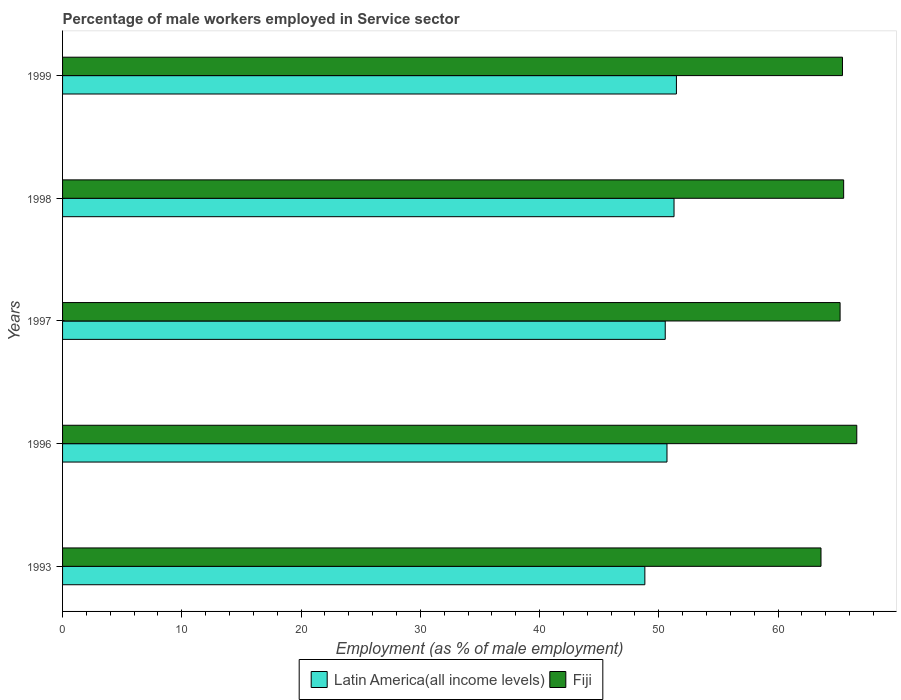Are the number of bars on each tick of the Y-axis equal?
Your response must be concise. Yes. How many bars are there on the 4th tick from the bottom?
Offer a very short reply. 2. What is the percentage of male workers employed in Service sector in Fiji in 1993?
Offer a very short reply. 63.6. Across all years, what is the maximum percentage of male workers employed in Service sector in Fiji?
Your answer should be compact. 66.6. Across all years, what is the minimum percentage of male workers employed in Service sector in Latin America(all income levels)?
Make the answer very short. 48.83. In which year was the percentage of male workers employed in Service sector in Fiji minimum?
Make the answer very short. 1993. What is the total percentage of male workers employed in Service sector in Fiji in the graph?
Offer a terse response. 326.3. What is the difference between the percentage of male workers employed in Service sector in Fiji in 1993 and that in 1998?
Give a very brief answer. -1.9. What is the difference between the percentage of male workers employed in Service sector in Fiji in 1993 and the percentage of male workers employed in Service sector in Latin America(all income levels) in 1997?
Provide a succinct answer. 13.06. What is the average percentage of male workers employed in Service sector in Fiji per year?
Ensure brevity in your answer.  65.26. In the year 1998, what is the difference between the percentage of male workers employed in Service sector in Latin America(all income levels) and percentage of male workers employed in Service sector in Fiji?
Your answer should be very brief. -14.22. What is the ratio of the percentage of male workers employed in Service sector in Fiji in 1996 to that in 1999?
Give a very brief answer. 1.02. Is the percentage of male workers employed in Service sector in Fiji in 1993 less than that in 1999?
Offer a very short reply. Yes. Is the difference between the percentage of male workers employed in Service sector in Latin America(all income levels) in 1997 and 1999 greater than the difference between the percentage of male workers employed in Service sector in Fiji in 1997 and 1999?
Provide a succinct answer. No. What is the difference between the highest and the second highest percentage of male workers employed in Service sector in Fiji?
Your answer should be compact. 1.1. What is the difference between the highest and the lowest percentage of male workers employed in Service sector in Latin America(all income levels)?
Offer a very short reply. 2.65. In how many years, is the percentage of male workers employed in Service sector in Fiji greater than the average percentage of male workers employed in Service sector in Fiji taken over all years?
Make the answer very short. 3. Is the sum of the percentage of male workers employed in Service sector in Fiji in 1996 and 1998 greater than the maximum percentage of male workers employed in Service sector in Latin America(all income levels) across all years?
Your response must be concise. Yes. What does the 2nd bar from the top in 1993 represents?
Make the answer very short. Latin America(all income levels). What does the 2nd bar from the bottom in 1996 represents?
Provide a short and direct response. Fiji. How many bars are there?
Keep it short and to the point. 10. Does the graph contain grids?
Offer a terse response. No. How many legend labels are there?
Provide a short and direct response. 2. How are the legend labels stacked?
Give a very brief answer. Horizontal. What is the title of the graph?
Ensure brevity in your answer.  Percentage of male workers employed in Service sector. What is the label or title of the X-axis?
Provide a short and direct response. Employment (as % of male employment). What is the Employment (as % of male employment) of Latin America(all income levels) in 1993?
Make the answer very short. 48.83. What is the Employment (as % of male employment) in Fiji in 1993?
Your answer should be compact. 63.6. What is the Employment (as % of male employment) in Latin America(all income levels) in 1996?
Your response must be concise. 50.68. What is the Employment (as % of male employment) in Fiji in 1996?
Offer a very short reply. 66.6. What is the Employment (as % of male employment) in Latin America(all income levels) in 1997?
Ensure brevity in your answer.  50.54. What is the Employment (as % of male employment) in Fiji in 1997?
Offer a very short reply. 65.2. What is the Employment (as % of male employment) of Latin America(all income levels) in 1998?
Provide a short and direct response. 51.28. What is the Employment (as % of male employment) in Fiji in 1998?
Offer a very short reply. 65.5. What is the Employment (as % of male employment) of Latin America(all income levels) in 1999?
Offer a terse response. 51.48. What is the Employment (as % of male employment) in Fiji in 1999?
Offer a terse response. 65.4. Across all years, what is the maximum Employment (as % of male employment) in Latin America(all income levels)?
Your response must be concise. 51.48. Across all years, what is the maximum Employment (as % of male employment) of Fiji?
Offer a terse response. 66.6. Across all years, what is the minimum Employment (as % of male employment) in Latin America(all income levels)?
Ensure brevity in your answer.  48.83. Across all years, what is the minimum Employment (as % of male employment) of Fiji?
Provide a short and direct response. 63.6. What is the total Employment (as % of male employment) in Latin America(all income levels) in the graph?
Your answer should be very brief. 252.8. What is the total Employment (as % of male employment) in Fiji in the graph?
Provide a succinct answer. 326.3. What is the difference between the Employment (as % of male employment) of Latin America(all income levels) in 1993 and that in 1996?
Provide a succinct answer. -1.86. What is the difference between the Employment (as % of male employment) in Latin America(all income levels) in 1993 and that in 1997?
Your answer should be very brief. -1.71. What is the difference between the Employment (as % of male employment) of Fiji in 1993 and that in 1997?
Your answer should be compact. -1.6. What is the difference between the Employment (as % of male employment) of Latin America(all income levels) in 1993 and that in 1998?
Give a very brief answer. -2.45. What is the difference between the Employment (as % of male employment) in Fiji in 1993 and that in 1998?
Make the answer very short. -1.9. What is the difference between the Employment (as % of male employment) of Latin America(all income levels) in 1993 and that in 1999?
Give a very brief answer. -2.65. What is the difference between the Employment (as % of male employment) in Fiji in 1993 and that in 1999?
Give a very brief answer. -1.8. What is the difference between the Employment (as % of male employment) in Latin America(all income levels) in 1996 and that in 1997?
Ensure brevity in your answer.  0.15. What is the difference between the Employment (as % of male employment) of Fiji in 1996 and that in 1997?
Provide a short and direct response. 1.4. What is the difference between the Employment (as % of male employment) in Latin America(all income levels) in 1996 and that in 1998?
Your response must be concise. -0.59. What is the difference between the Employment (as % of male employment) in Latin America(all income levels) in 1996 and that in 1999?
Provide a succinct answer. -0.79. What is the difference between the Employment (as % of male employment) of Latin America(all income levels) in 1997 and that in 1998?
Offer a terse response. -0.74. What is the difference between the Employment (as % of male employment) in Fiji in 1997 and that in 1998?
Your response must be concise. -0.3. What is the difference between the Employment (as % of male employment) of Latin America(all income levels) in 1997 and that in 1999?
Your response must be concise. -0.94. What is the difference between the Employment (as % of male employment) in Fiji in 1997 and that in 1999?
Your answer should be compact. -0.2. What is the difference between the Employment (as % of male employment) of Latin America(all income levels) in 1998 and that in 1999?
Ensure brevity in your answer.  -0.2. What is the difference between the Employment (as % of male employment) of Fiji in 1998 and that in 1999?
Your response must be concise. 0.1. What is the difference between the Employment (as % of male employment) of Latin America(all income levels) in 1993 and the Employment (as % of male employment) of Fiji in 1996?
Give a very brief answer. -17.77. What is the difference between the Employment (as % of male employment) of Latin America(all income levels) in 1993 and the Employment (as % of male employment) of Fiji in 1997?
Ensure brevity in your answer.  -16.37. What is the difference between the Employment (as % of male employment) of Latin America(all income levels) in 1993 and the Employment (as % of male employment) of Fiji in 1998?
Your answer should be very brief. -16.67. What is the difference between the Employment (as % of male employment) of Latin America(all income levels) in 1993 and the Employment (as % of male employment) of Fiji in 1999?
Provide a succinct answer. -16.57. What is the difference between the Employment (as % of male employment) in Latin America(all income levels) in 1996 and the Employment (as % of male employment) in Fiji in 1997?
Your answer should be very brief. -14.52. What is the difference between the Employment (as % of male employment) in Latin America(all income levels) in 1996 and the Employment (as % of male employment) in Fiji in 1998?
Your answer should be very brief. -14.82. What is the difference between the Employment (as % of male employment) in Latin America(all income levels) in 1996 and the Employment (as % of male employment) in Fiji in 1999?
Your answer should be very brief. -14.72. What is the difference between the Employment (as % of male employment) of Latin America(all income levels) in 1997 and the Employment (as % of male employment) of Fiji in 1998?
Provide a succinct answer. -14.96. What is the difference between the Employment (as % of male employment) in Latin America(all income levels) in 1997 and the Employment (as % of male employment) in Fiji in 1999?
Keep it short and to the point. -14.86. What is the difference between the Employment (as % of male employment) of Latin America(all income levels) in 1998 and the Employment (as % of male employment) of Fiji in 1999?
Provide a short and direct response. -14.12. What is the average Employment (as % of male employment) of Latin America(all income levels) per year?
Your response must be concise. 50.56. What is the average Employment (as % of male employment) of Fiji per year?
Your answer should be very brief. 65.26. In the year 1993, what is the difference between the Employment (as % of male employment) in Latin America(all income levels) and Employment (as % of male employment) in Fiji?
Your response must be concise. -14.77. In the year 1996, what is the difference between the Employment (as % of male employment) in Latin America(all income levels) and Employment (as % of male employment) in Fiji?
Provide a succinct answer. -15.92. In the year 1997, what is the difference between the Employment (as % of male employment) in Latin America(all income levels) and Employment (as % of male employment) in Fiji?
Provide a short and direct response. -14.66. In the year 1998, what is the difference between the Employment (as % of male employment) of Latin America(all income levels) and Employment (as % of male employment) of Fiji?
Ensure brevity in your answer.  -14.22. In the year 1999, what is the difference between the Employment (as % of male employment) of Latin America(all income levels) and Employment (as % of male employment) of Fiji?
Your answer should be compact. -13.92. What is the ratio of the Employment (as % of male employment) in Latin America(all income levels) in 1993 to that in 1996?
Make the answer very short. 0.96. What is the ratio of the Employment (as % of male employment) of Fiji in 1993 to that in 1996?
Your answer should be compact. 0.95. What is the ratio of the Employment (as % of male employment) in Latin America(all income levels) in 1993 to that in 1997?
Offer a very short reply. 0.97. What is the ratio of the Employment (as % of male employment) of Fiji in 1993 to that in 1997?
Ensure brevity in your answer.  0.98. What is the ratio of the Employment (as % of male employment) in Latin America(all income levels) in 1993 to that in 1998?
Offer a terse response. 0.95. What is the ratio of the Employment (as % of male employment) of Fiji in 1993 to that in 1998?
Make the answer very short. 0.97. What is the ratio of the Employment (as % of male employment) of Latin America(all income levels) in 1993 to that in 1999?
Keep it short and to the point. 0.95. What is the ratio of the Employment (as % of male employment) in Fiji in 1993 to that in 1999?
Make the answer very short. 0.97. What is the ratio of the Employment (as % of male employment) in Fiji in 1996 to that in 1997?
Offer a very short reply. 1.02. What is the ratio of the Employment (as % of male employment) in Fiji in 1996 to that in 1998?
Keep it short and to the point. 1.02. What is the ratio of the Employment (as % of male employment) of Latin America(all income levels) in 1996 to that in 1999?
Your response must be concise. 0.98. What is the ratio of the Employment (as % of male employment) of Fiji in 1996 to that in 1999?
Your answer should be very brief. 1.02. What is the ratio of the Employment (as % of male employment) in Latin America(all income levels) in 1997 to that in 1998?
Make the answer very short. 0.99. What is the ratio of the Employment (as % of male employment) of Latin America(all income levels) in 1997 to that in 1999?
Make the answer very short. 0.98. What is the ratio of the Employment (as % of male employment) in Fiji in 1998 to that in 1999?
Offer a very short reply. 1. What is the difference between the highest and the second highest Employment (as % of male employment) in Latin America(all income levels)?
Your answer should be compact. 0.2. What is the difference between the highest and the lowest Employment (as % of male employment) of Latin America(all income levels)?
Your answer should be very brief. 2.65. 